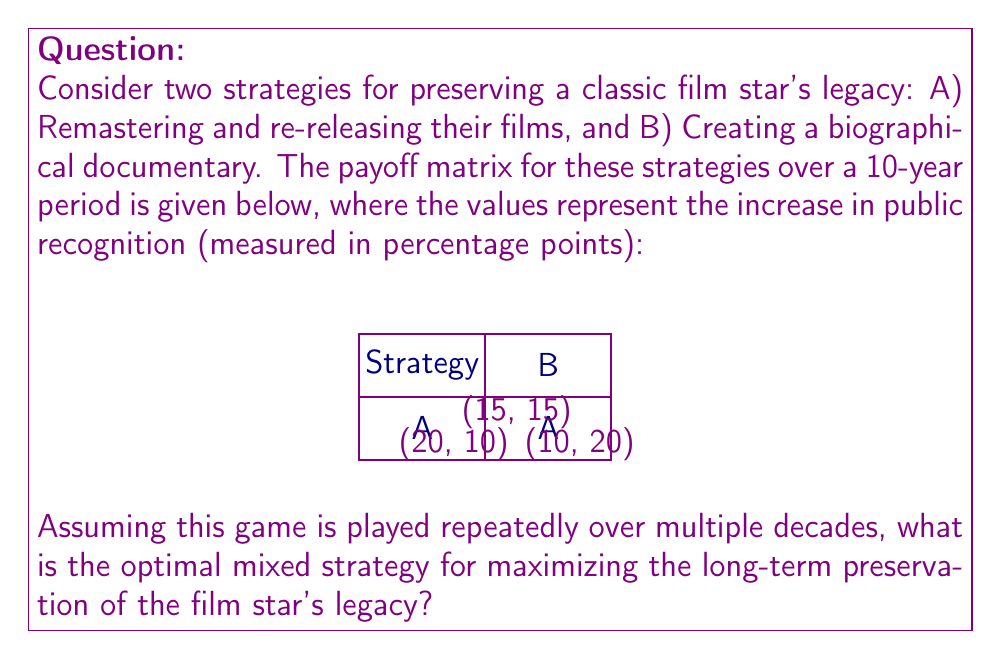Show me your answer to this math problem. To solve this problem, we'll use the concept of mixed strategy Nash equilibrium from game theory. Let's approach this step-by-step:

1) Let $p$ be the probability of choosing strategy A, and $(1-p)$ the probability of choosing strategy B.

2) For a mixed strategy equilibrium, the expected payoff of both strategies should be equal:

   $15p + 20(1-p) = 15p + 10(1-p)$

3) Simplify the equation:

   $15p + 20 - 20p = 15p + 10 - 10p$
   $-5p + 20 = 5p + 10$
   $10 = 10p$
   $p = 1$

4) This result suggests that the pure strategy A (always choosing to remaster and re-release films) is optimal.

5) To verify, let's calculate the expected payoff for each pure strategy:

   Strategy A: $15 * 1 + 20 * 0 = 15$
   Strategy B: $10 * 1 + 15 * 0 = 10$

6) Indeed, strategy A yields a higher expected payoff in the long run.

7) Intuitively, this makes sense because remastering and re-releasing films directly exposes the audience to the star's work, which is likely to have a more substantial impact on preserving their legacy compared to a biographical documentary.
Answer: Pure strategy A (always remaster and re-release films) with $p = 1$ 